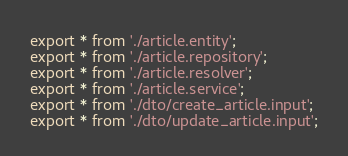Convert code to text. <code><loc_0><loc_0><loc_500><loc_500><_TypeScript_>export * from './article.entity';
export * from './article.repository';
export * from './article.resolver';
export * from './article.service';
export * from './dto/create_article.input';
export * from './dto/update_article.input';
</code> 